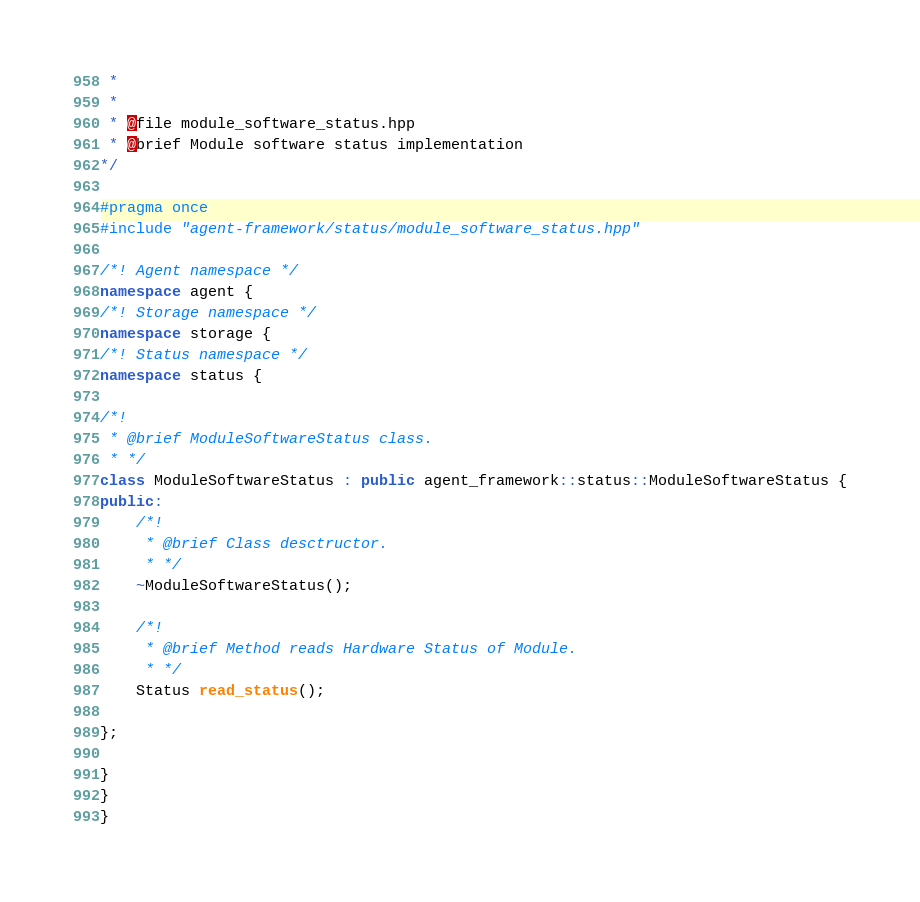Convert code to text. <code><loc_0><loc_0><loc_500><loc_500><_C++_> *
 *
 * @file module_software_status.hpp
 * @brief Module software status implementation
*/

#pragma once
#include "agent-framework/status/module_software_status.hpp"

/*! Agent namespace */
namespace agent {
/*! Storage namespace */
namespace storage {
/*! Status namespace */
namespace status {

/*!
 * @brief ModuleSoftwareStatus class.
 * */
class ModuleSoftwareStatus : public agent_framework::status::ModuleSoftwareStatus {
public:
    /*!
     * @brief Class desctructor.
     * */
    ~ModuleSoftwareStatus();

    /*!
     * @brief Method reads Hardware Status of Module.
     * */
    Status read_status();

};

}
}
}

</code> 